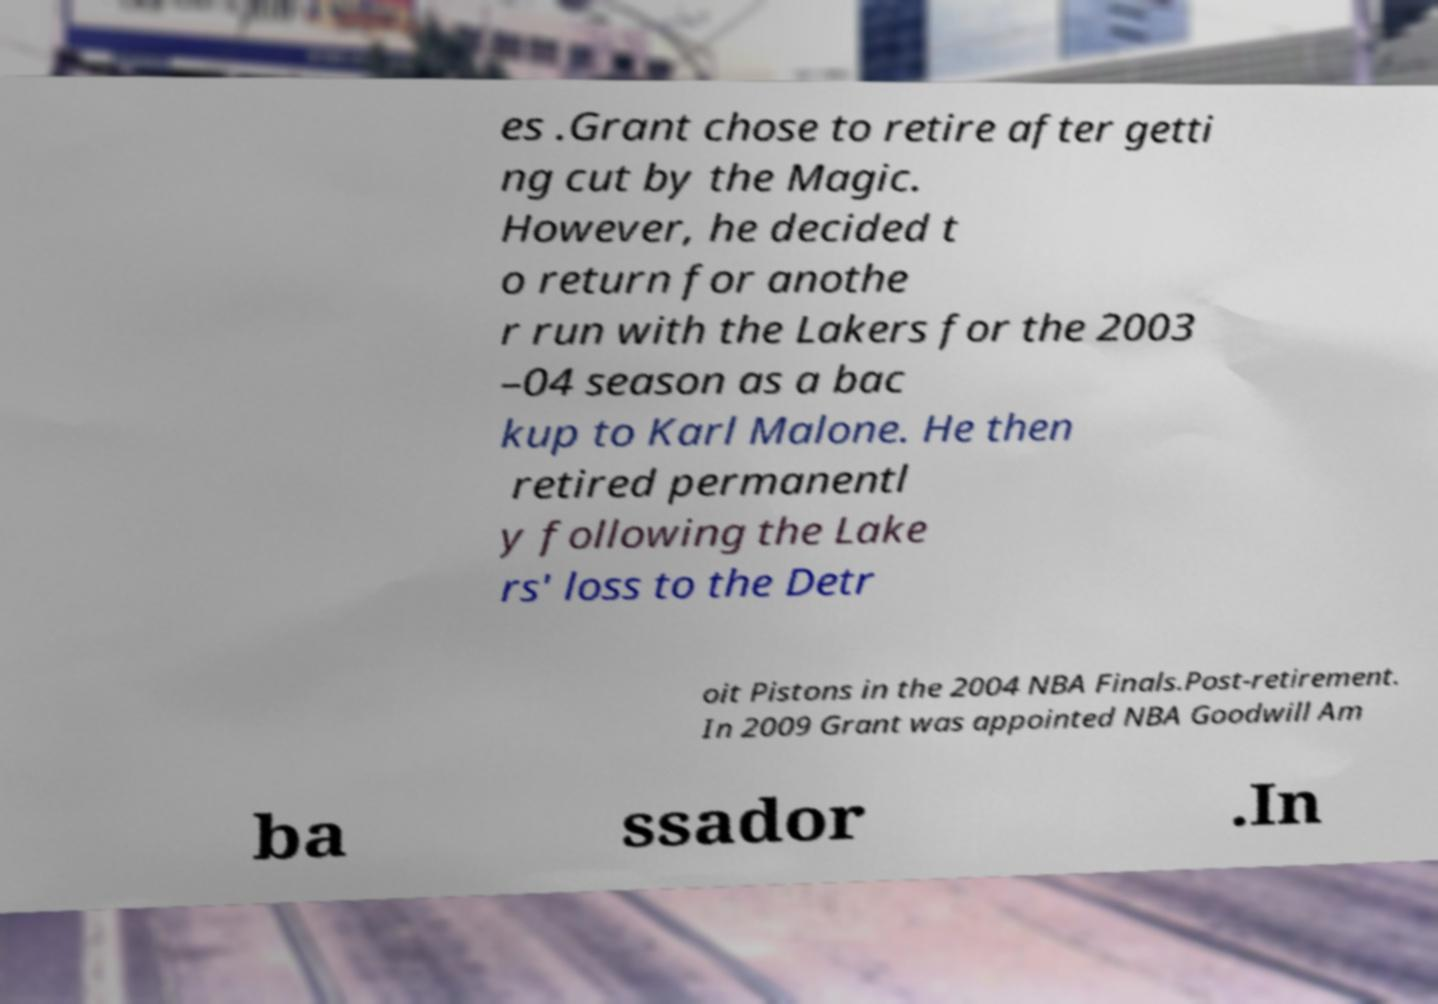Could you extract and type out the text from this image? es .Grant chose to retire after getti ng cut by the Magic. However, he decided t o return for anothe r run with the Lakers for the 2003 –04 season as a bac kup to Karl Malone. He then retired permanentl y following the Lake rs' loss to the Detr oit Pistons in the 2004 NBA Finals.Post-retirement. In 2009 Grant was appointed NBA Goodwill Am ba ssador .In 